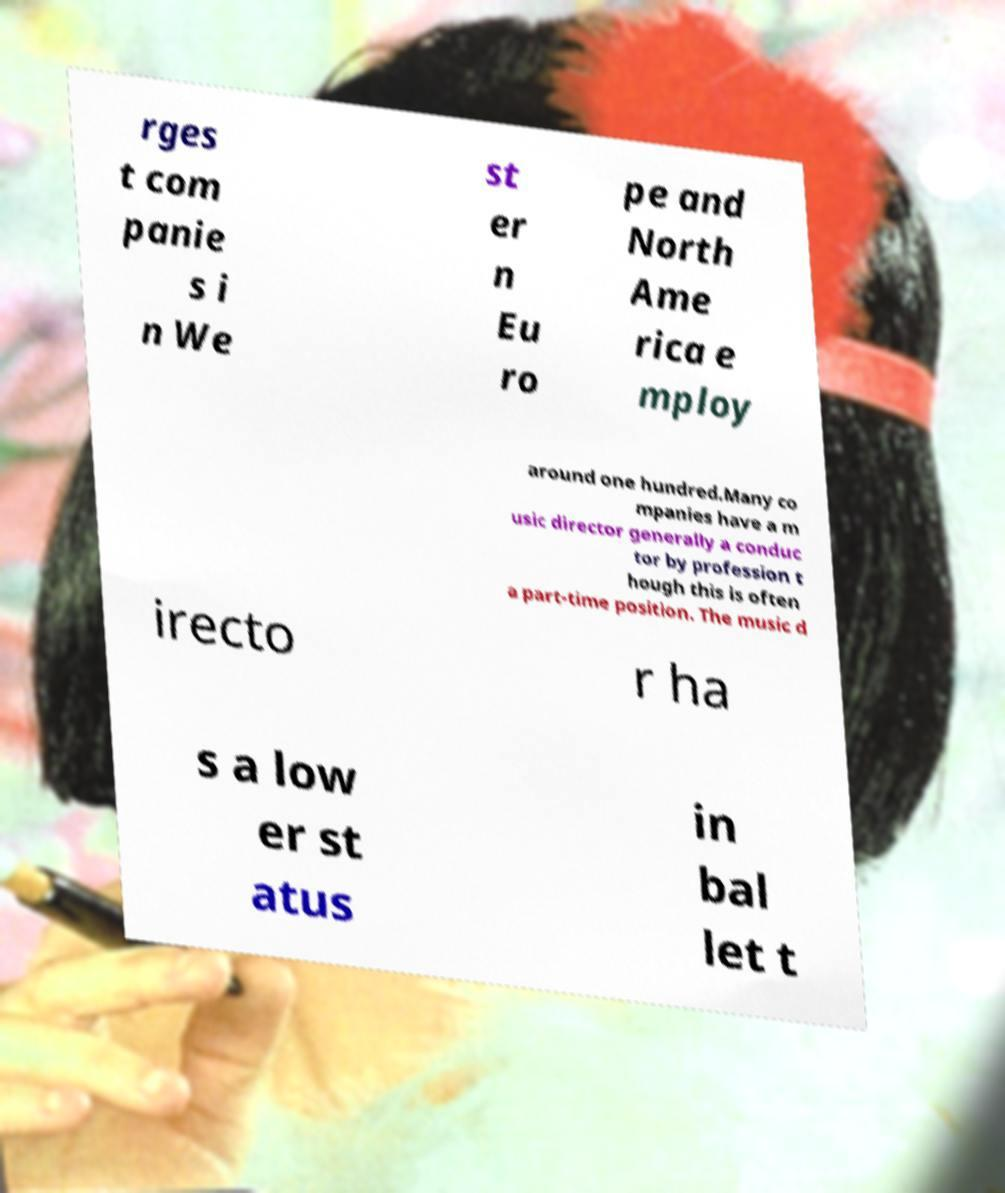I need the written content from this picture converted into text. Can you do that? rges t com panie s i n We st er n Eu ro pe and North Ame rica e mploy around one hundred.Many co mpanies have a m usic director generally a conduc tor by profession t hough this is often a part-time position. The music d irecto r ha s a low er st atus in bal let t 